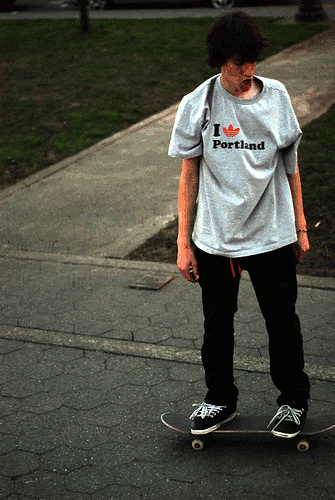Describe the objects in this image and their specific colors. I can see people in black, darkgray, lightgray, and gray tones and skateboard in black and gray tones in this image. 